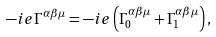Convert formula to latex. <formula><loc_0><loc_0><loc_500><loc_500>- i e \Gamma ^ { \alpha \beta \mu } = - i e \left ( \Gamma _ { 0 } ^ { \alpha \beta \mu } + \Gamma _ { 1 } ^ { \alpha \beta \mu } \right ) ,</formula> 